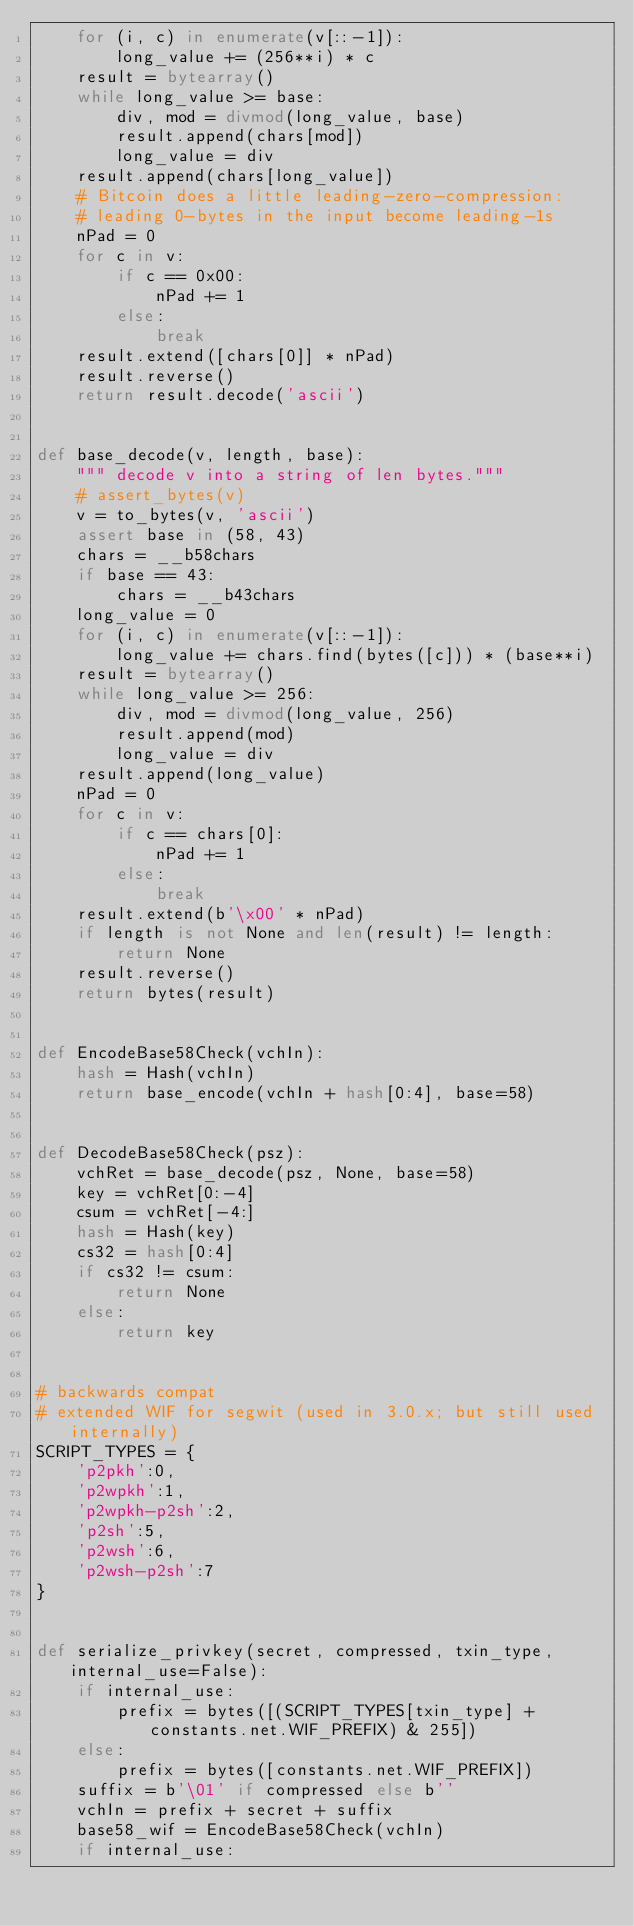<code> <loc_0><loc_0><loc_500><loc_500><_Python_>    for (i, c) in enumerate(v[::-1]):
        long_value += (256**i) * c
    result = bytearray()
    while long_value >= base:
        div, mod = divmod(long_value, base)
        result.append(chars[mod])
        long_value = div
    result.append(chars[long_value])
    # Bitcoin does a little leading-zero-compression:
    # leading 0-bytes in the input become leading-1s
    nPad = 0
    for c in v:
        if c == 0x00:
            nPad += 1
        else:
            break
    result.extend([chars[0]] * nPad)
    result.reverse()
    return result.decode('ascii')


def base_decode(v, length, base):
    """ decode v into a string of len bytes."""
    # assert_bytes(v)
    v = to_bytes(v, 'ascii')
    assert base in (58, 43)
    chars = __b58chars
    if base == 43:
        chars = __b43chars
    long_value = 0
    for (i, c) in enumerate(v[::-1]):
        long_value += chars.find(bytes([c])) * (base**i)
    result = bytearray()
    while long_value >= 256:
        div, mod = divmod(long_value, 256)
        result.append(mod)
        long_value = div
    result.append(long_value)
    nPad = 0
    for c in v:
        if c == chars[0]:
            nPad += 1
        else:
            break
    result.extend(b'\x00' * nPad)
    if length is not None and len(result) != length:
        return None
    result.reverse()
    return bytes(result)


def EncodeBase58Check(vchIn):
    hash = Hash(vchIn)
    return base_encode(vchIn + hash[0:4], base=58)


def DecodeBase58Check(psz):
    vchRet = base_decode(psz, None, base=58)
    key = vchRet[0:-4]
    csum = vchRet[-4:]
    hash = Hash(key)
    cs32 = hash[0:4]
    if cs32 != csum:
        return None
    else:
        return key


# backwards compat
# extended WIF for segwit (used in 3.0.x; but still used internally)
SCRIPT_TYPES = {
    'p2pkh':0,
    'p2wpkh':1,
    'p2wpkh-p2sh':2,
    'p2sh':5,
    'p2wsh':6,
    'p2wsh-p2sh':7
}


def serialize_privkey(secret, compressed, txin_type, internal_use=False):
    if internal_use:
        prefix = bytes([(SCRIPT_TYPES[txin_type] + constants.net.WIF_PREFIX) & 255])
    else:
        prefix = bytes([constants.net.WIF_PREFIX])
    suffix = b'\01' if compressed else b''
    vchIn = prefix + secret + suffix
    base58_wif = EncodeBase58Check(vchIn)
    if internal_use:</code> 